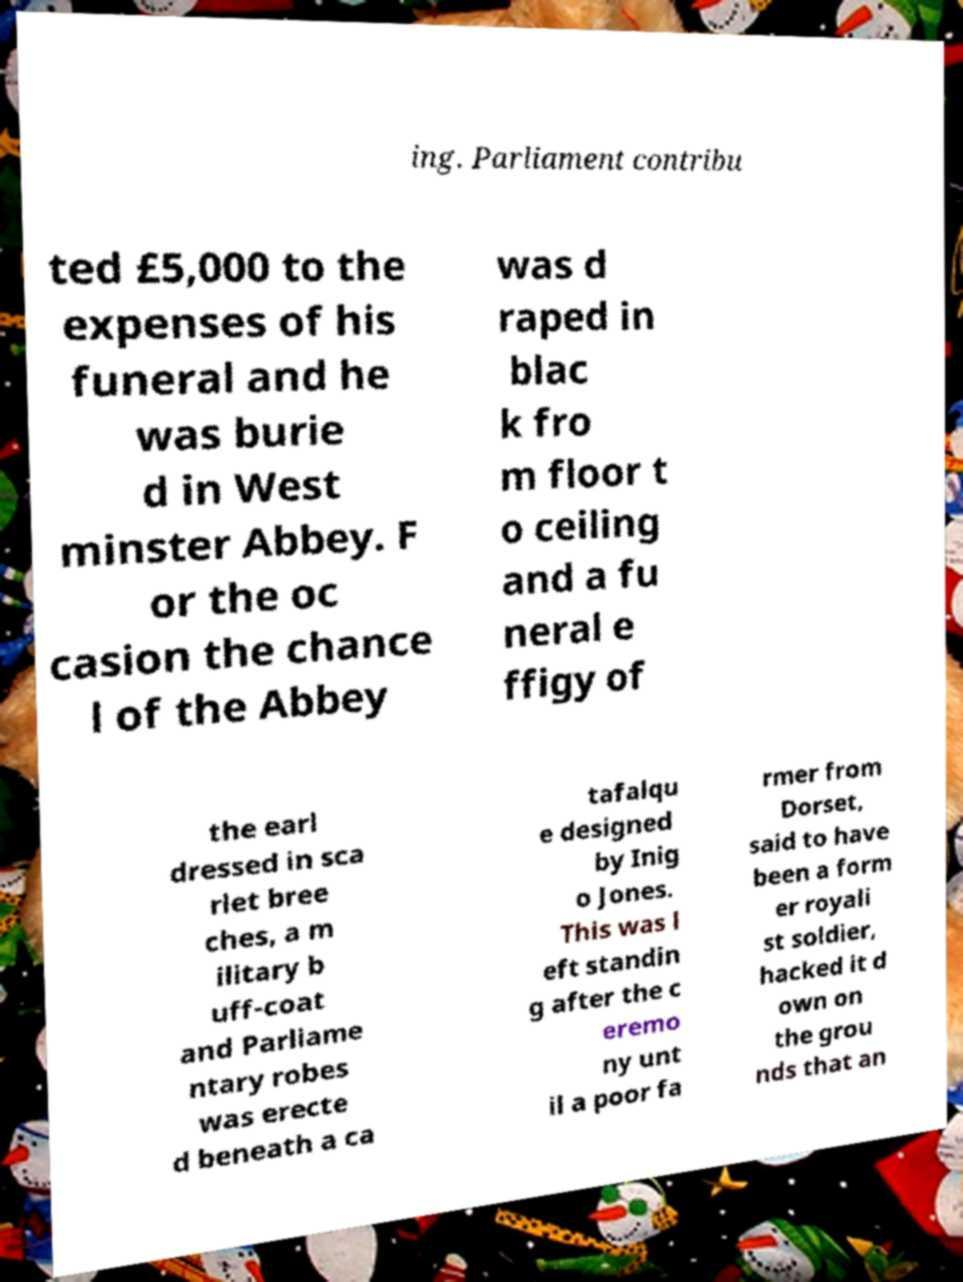There's text embedded in this image that I need extracted. Can you transcribe it verbatim? ing. Parliament contribu ted £5,000 to the expenses of his funeral and he was burie d in West minster Abbey. F or the oc casion the chance l of the Abbey was d raped in blac k fro m floor t o ceiling and a fu neral e ffigy of the earl dressed in sca rlet bree ches, a m ilitary b uff-coat and Parliame ntary robes was erecte d beneath a ca tafalqu e designed by Inig o Jones. This was l eft standin g after the c eremo ny unt il a poor fa rmer from Dorset, said to have been a form er royali st soldier, hacked it d own on the grou nds that an 